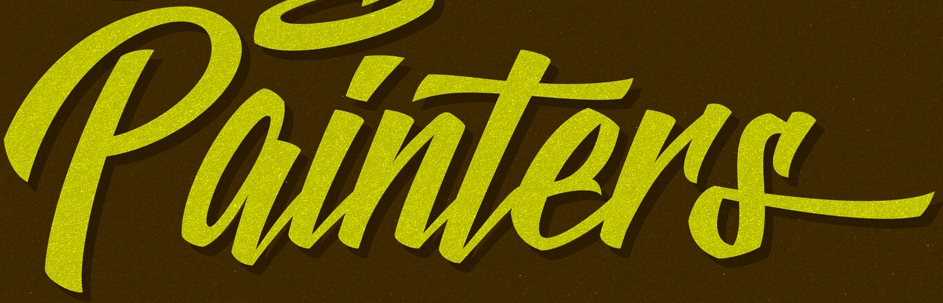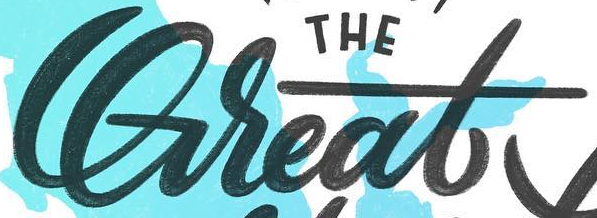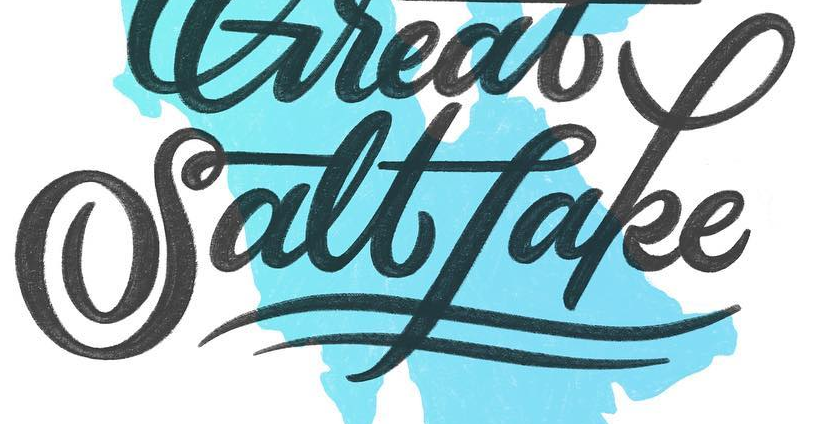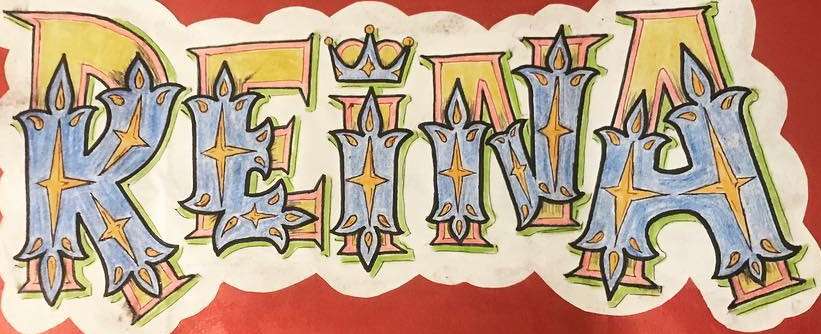What words are shown in these images in order, separated by a semicolon? painTers; Great; Saltfake; REINA 